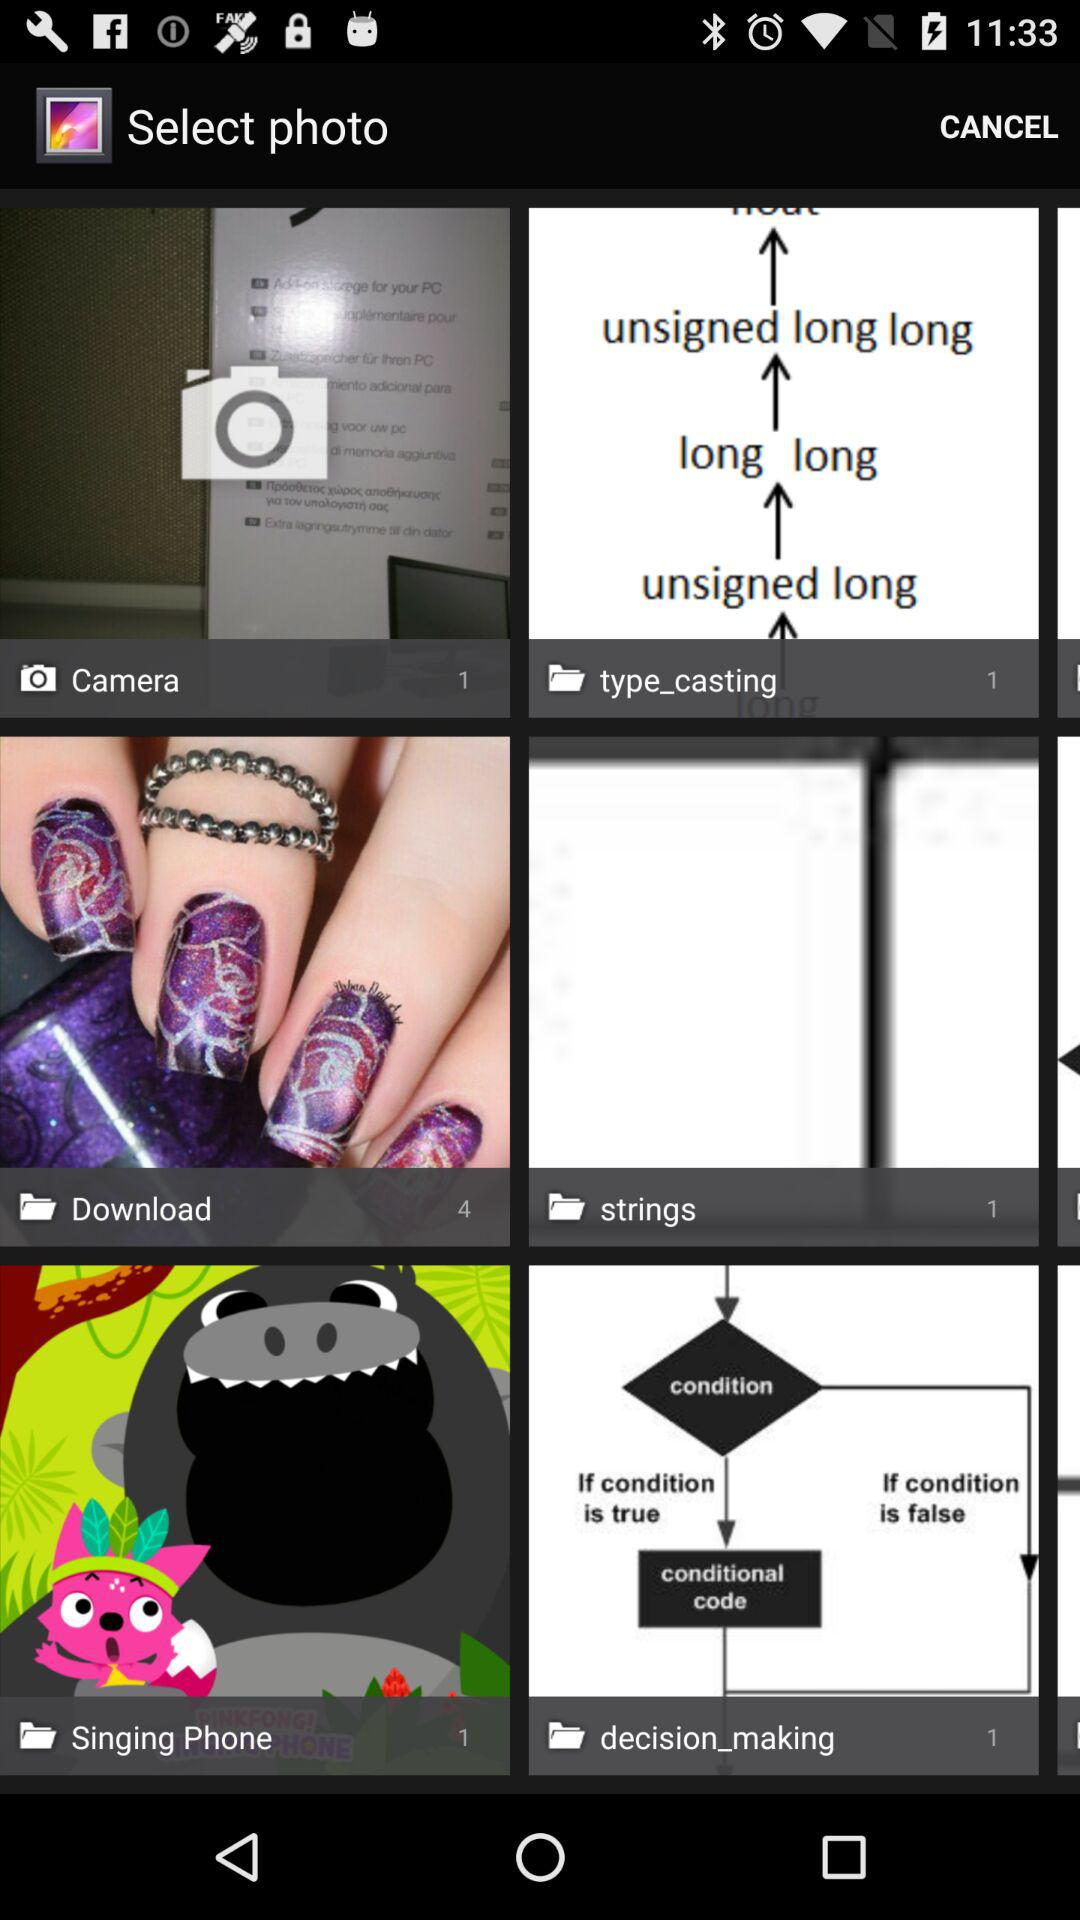What is the number of photos in the "Camera" folder? There is 1 photo in the "Camera" folder. 